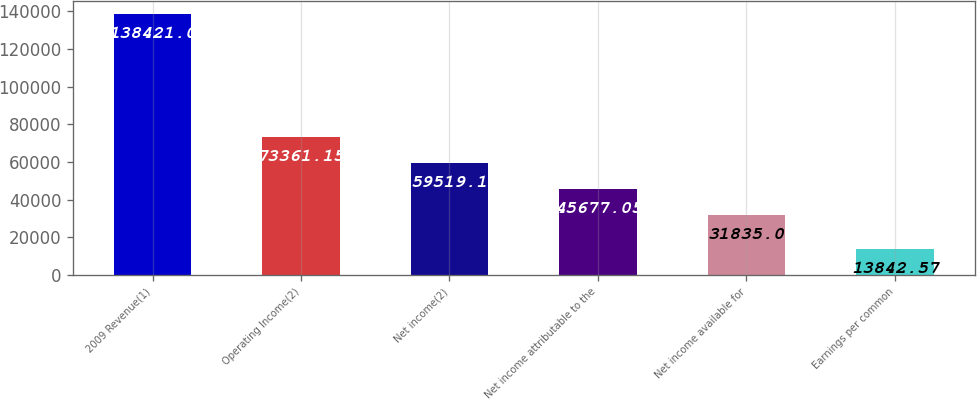<chart> <loc_0><loc_0><loc_500><loc_500><bar_chart><fcel>2009 Revenue(1)<fcel>Operating Income(2)<fcel>Net income(2)<fcel>Net income attributable to the<fcel>Net income available for<fcel>Earnings per common<nl><fcel>138421<fcel>73361.1<fcel>59519.1<fcel>45677.1<fcel>31835<fcel>13842.6<nl></chart> 